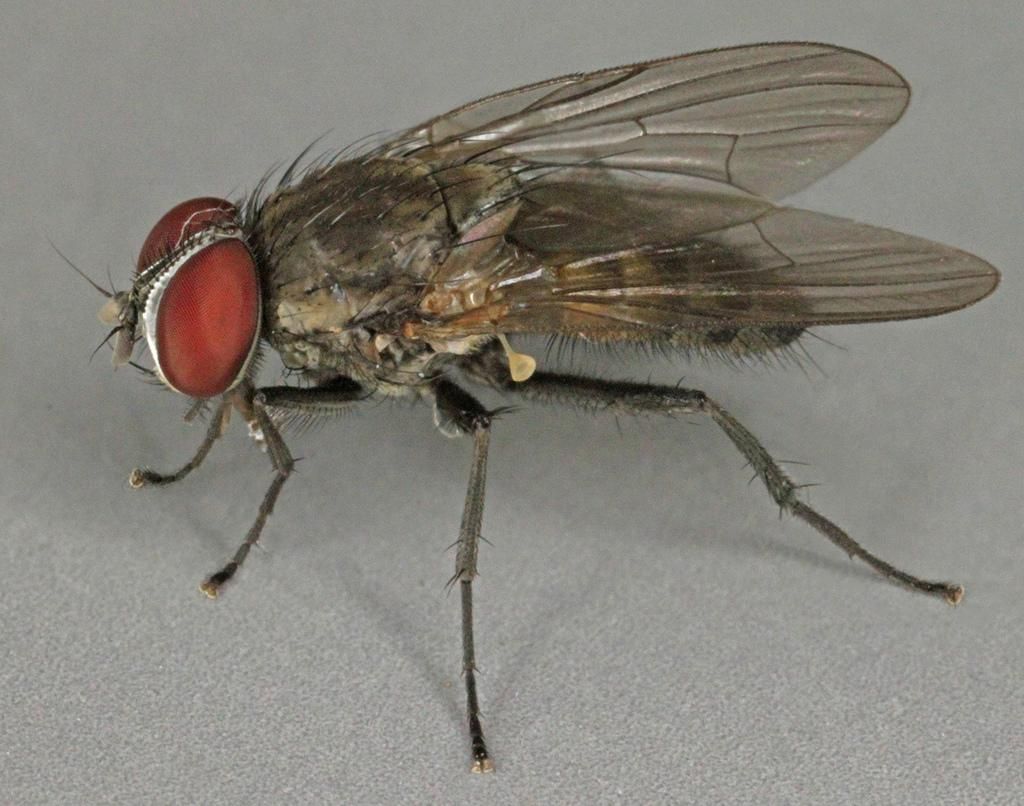What is present in the image? There is a fly in the image. Where is the fly located? The fly is on a surface. What type of tomatoes can be seen growing on the cushion in the image? There are no tomatoes or cushions present in the image; it only features a fly on a surface. 